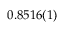Convert formula to latex. <formula><loc_0><loc_0><loc_500><loc_500>0 . 8 5 1 6 ( 1 )</formula> 